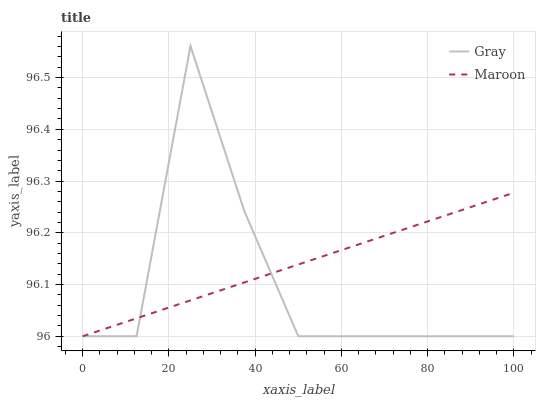Does Gray have the minimum area under the curve?
Answer yes or no. Yes. Does Maroon have the maximum area under the curve?
Answer yes or no. Yes. Does Maroon have the minimum area under the curve?
Answer yes or no. No. Is Maroon the smoothest?
Answer yes or no. Yes. Is Gray the roughest?
Answer yes or no. Yes. Is Maroon the roughest?
Answer yes or no. No. Does Gray have the lowest value?
Answer yes or no. Yes. Does Gray have the highest value?
Answer yes or no. Yes. Does Maroon have the highest value?
Answer yes or no. No. Does Maroon intersect Gray?
Answer yes or no. Yes. Is Maroon less than Gray?
Answer yes or no. No. Is Maroon greater than Gray?
Answer yes or no. No. 